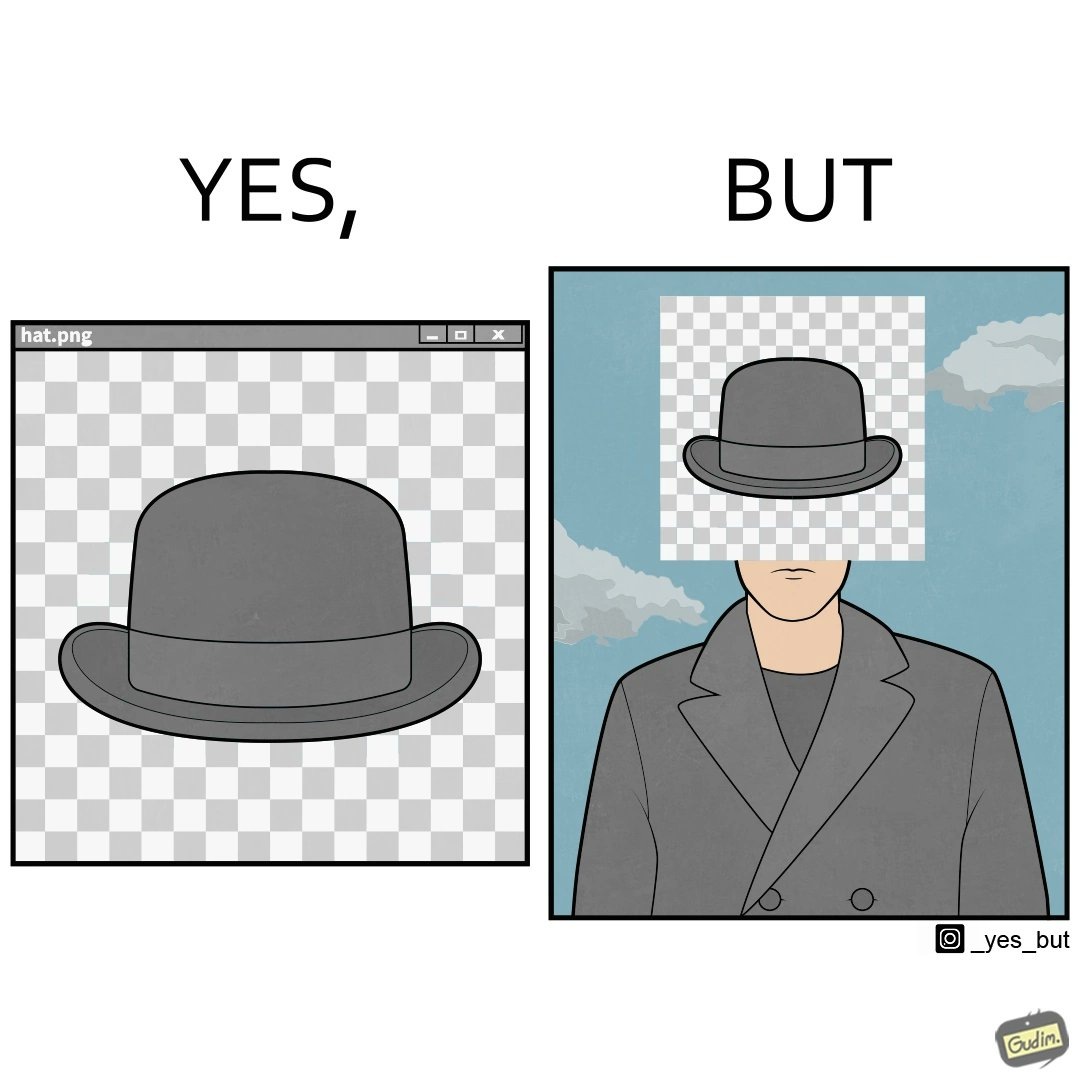Would you classify this image as satirical? Yes, this image is satirical. 